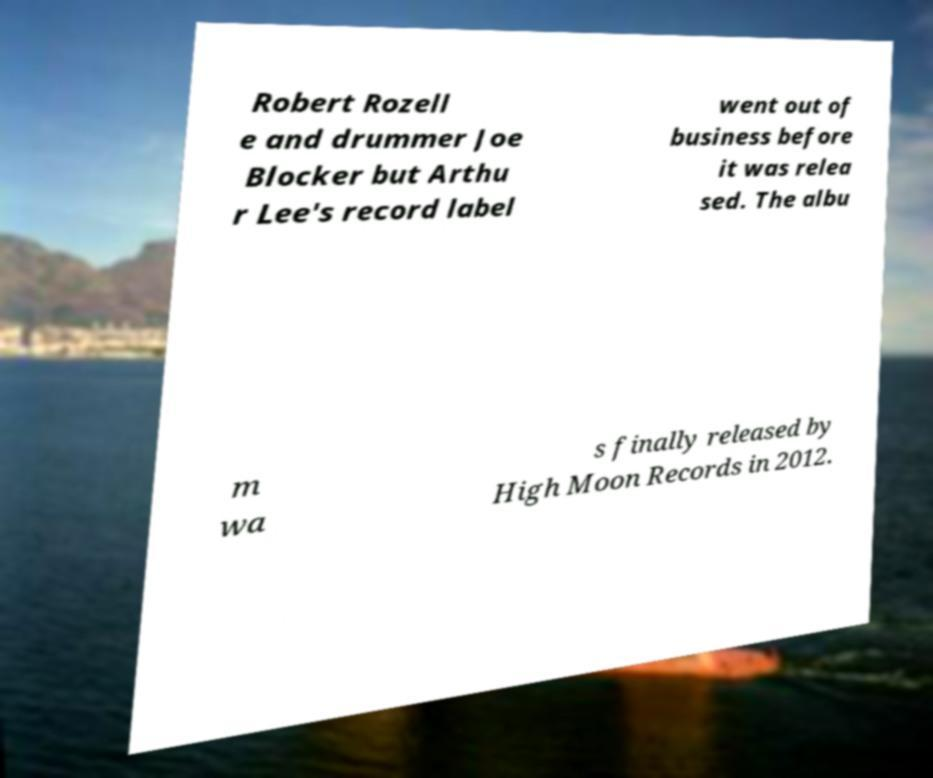Can you read and provide the text displayed in the image?This photo seems to have some interesting text. Can you extract and type it out for me? Robert Rozell e and drummer Joe Blocker but Arthu r Lee's record label went out of business before it was relea sed. The albu m wa s finally released by High Moon Records in 2012. 